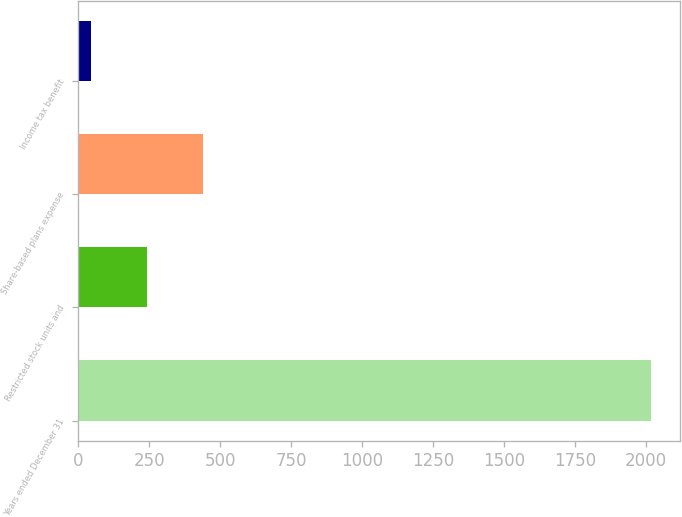Convert chart to OTSL. <chart><loc_0><loc_0><loc_500><loc_500><bar_chart><fcel>Years ended December 31<fcel>Restricted stock units and<fcel>Share-based plans expense<fcel>Income tax benefit<nl><fcel>2018<fcel>243.2<fcel>440.4<fcel>46<nl></chart> 